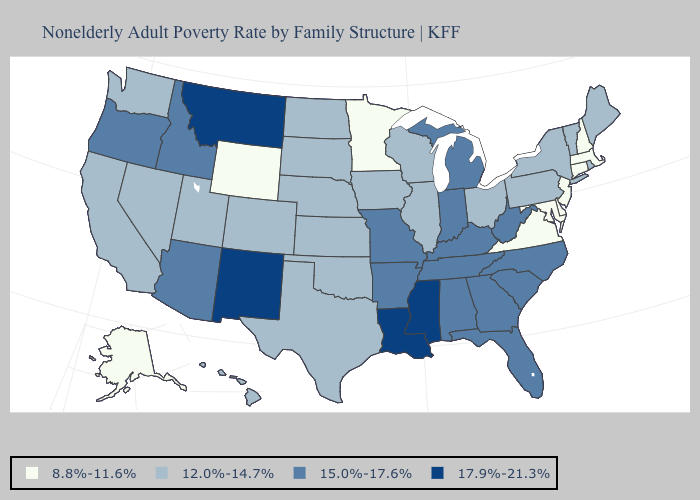Does New Hampshire have the lowest value in the USA?
Quick response, please. Yes. Which states have the highest value in the USA?
Keep it brief. Louisiana, Mississippi, Montana, New Mexico. Does Louisiana have the highest value in the USA?
Keep it brief. Yes. Among the states that border Arizona , does New Mexico have the lowest value?
Be succinct. No. Which states have the lowest value in the USA?
Write a very short answer. Alaska, Connecticut, Delaware, Maryland, Massachusetts, Minnesota, New Hampshire, New Jersey, Virginia, Wyoming. How many symbols are there in the legend?
Concise answer only. 4. What is the value of Utah?
Write a very short answer. 12.0%-14.7%. What is the highest value in states that border Virginia?
Keep it brief. 15.0%-17.6%. What is the value of Minnesota?
Give a very brief answer. 8.8%-11.6%. Among the states that border Nebraska , which have the highest value?
Quick response, please. Missouri. What is the value of West Virginia?
Give a very brief answer. 15.0%-17.6%. Which states hav the highest value in the MidWest?
Be succinct. Indiana, Michigan, Missouri. Does the first symbol in the legend represent the smallest category?
Be succinct. Yes. What is the highest value in the USA?
Write a very short answer. 17.9%-21.3%. 